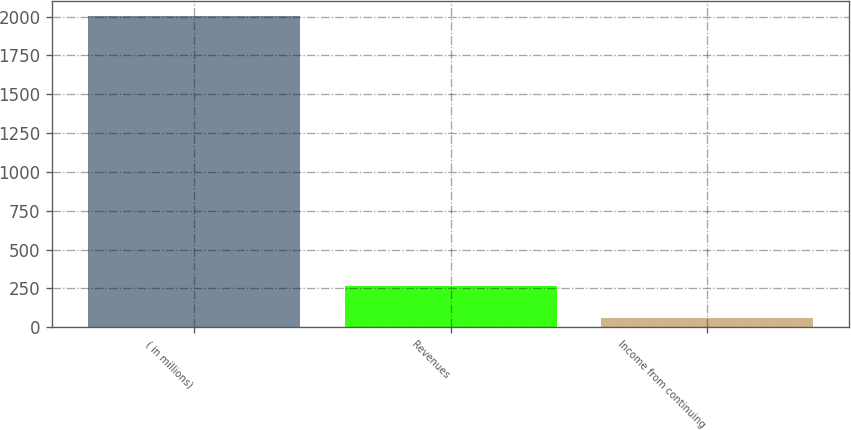Convert chart to OTSL. <chart><loc_0><loc_0><loc_500><loc_500><bar_chart><fcel>( in millions)<fcel>Revenues<fcel>Income from continuing<nl><fcel>2002<fcel>267<fcel>61<nl></chart> 